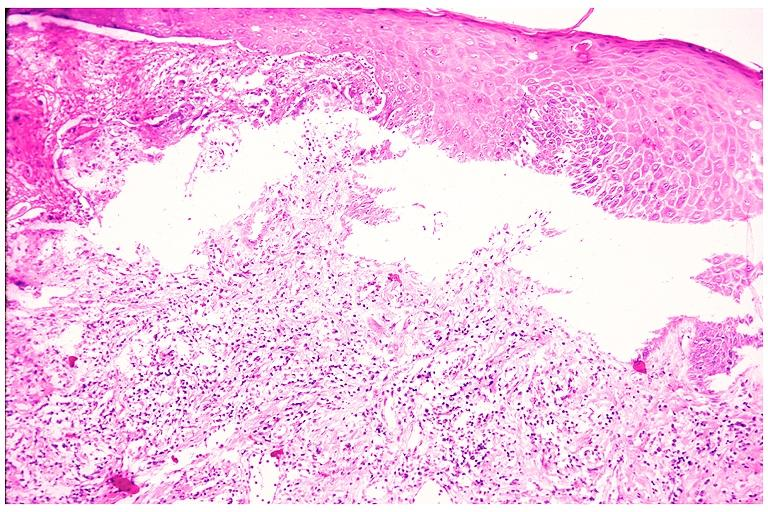does notochord show cicatricial pemphigoid?
Answer the question using a single word or phrase. No 